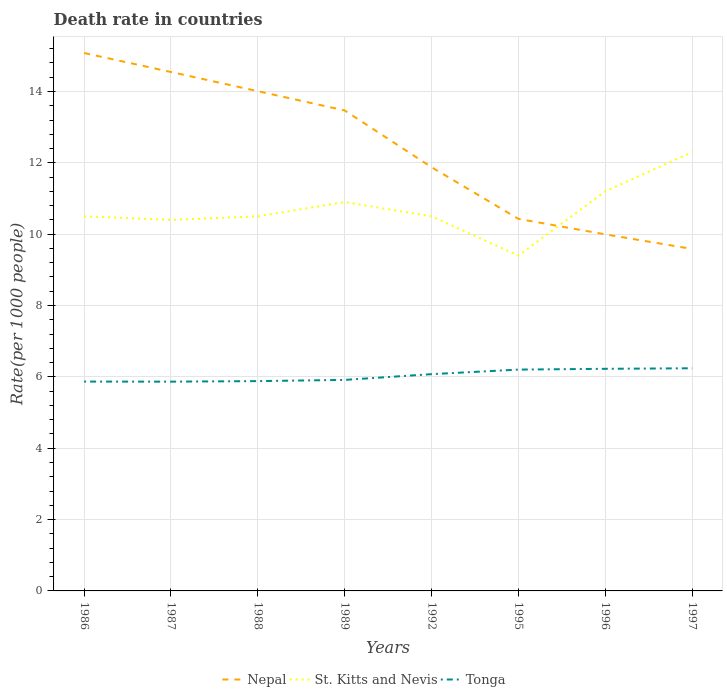Does the line corresponding to Tonga intersect with the line corresponding to Nepal?
Ensure brevity in your answer.  No. Is the number of lines equal to the number of legend labels?
Keep it short and to the point. Yes. Across all years, what is the maximum death rate in Nepal?
Your answer should be very brief. 9.59. What is the total death rate in Tonga in the graph?
Keep it short and to the point. -0.31. What is the difference between the highest and the lowest death rate in Nepal?
Give a very brief answer. 4. Is the death rate in Tonga strictly greater than the death rate in St. Kitts and Nevis over the years?
Provide a short and direct response. Yes. How many lines are there?
Provide a succinct answer. 3. Are the values on the major ticks of Y-axis written in scientific E-notation?
Your answer should be very brief. No. Does the graph contain grids?
Provide a succinct answer. Yes. Where does the legend appear in the graph?
Your answer should be compact. Bottom center. How many legend labels are there?
Your response must be concise. 3. How are the legend labels stacked?
Provide a short and direct response. Horizontal. What is the title of the graph?
Provide a short and direct response. Death rate in countries. What is the label or title of the X-axis?
Make the answer very short. Years. What is the label or title of the Y-axis?
Offer a very short reply. Rate(per 1000 people). What is the Rate(per 1000 people) of Nepal in 1986?
Keep it short and to the point. 15.08. What is the Rate(per 1000 people) of Tonga in 1986?
Provide a succinct answer. 5.87. What is the Rate(per 1000 people) of Nepal in 1987?
Ensure brevity in your answer.  14.55. What is the Rate(per 1000 people) in St. Kitts and Nevis in 1987?
Offer a terse response. 10.4. What is the Rate(per 1000 people) of Tonga in 1987?
Keep it short and to the point. 5.87. What is the Rate(per 1000 people) in Nepal in 1988?
Keep it short and to the point. 14.01. What is the Rate(per 1000 people) in St. Kitts and Nevis in 1988?
Your response must be concise. 10.5. What is the Rate(per 1000 people) in Tonga in 1988?
Your response must be concise. 5.88. What is the Rate(per 1000 people) in Nepal in 1989?
Keep it short and to the point. 13.47. What is the Rate(per 1000 people) of Tonga in 1989?
Ensure brevity in your answer.  5.92. What is the Rate(per 1000 people) in Nepal in 1992?
Offer a very short reply. 11.88. What is the Rate(per 1000 people) of St. Kitts and Nevis in 1992?
Give a very brief answer. 10.5. What is the Rate(per 1000 people) of Tonga in 1992?
Ensure brevity in your answer.  6.08. What is the Rate(per 1000 people) in Nepal in 1995?
Ensure brevity in your answer.  10.43. What is the Rate(per 1000 people) of Tonga in 1995?
Offer a very short reply. 6.2. What is the Rate(per 1000 people) of Nepal in 1996?
Offer a terse response. 9.99. What is the Rate(per 1000 people) of Tonga in 1996?
Your response must be concise. 6.23. What is the Rate(per 1000 people) in Nepal in 1997?
Give a very brief answer. 9.59. What is the Rate(per 1000 people) in St. Kitts and Nevis in 1997?
Keep it short and to the point. 12.3. What is the Rate(per 1000 people) in Tonga in 1997?
Provide a succinct answer. 6.24. Across all years, what is the maximum Rate(per 1000 people) in Nepal?
Your answer should be very brief. 15.08. Across all years, what is the maximum Rate(per 1000 people) in Tonga?
Make the answer very short. 6.24. Across all years, what is the minimum Rate(per 1000 people) in Nepal?
Provide a succinct answer. 9.59. Across all years, what is the minimum Rate(per 1000 people) of Tonga?
Offer a terse response. 5.87. What is the total Rate(per 1000 people) of Nepal in the graph?
Keep it short and to the point. 98.99. What is the total Rate(per 1000 people) in St. Kitts and Nevis in the graph?
Keep it short and to the point. 85.7. What is the total Rate(per 1000 people) of Tonga in the graph?
Offer a very short reply. 48.28. What is the difference between the Rate(per 1000 people) in Nepal in 1986 and that in 1987?
Your response must be concise. 0.53. What is the difference between the Rate(per 1000 people) in St. Kitts and Nevis in 1986 and that in 1987?
Your answer should be very brief. 0.1. What is the difference between the Rate(per 1000 people) of Tonga in 1986 and that in 1987?
Provide a short and direct response. 0. What is the difference between the Rate(per 1000 people) of Nepal in 1986 and that in 1988?
Make the answer very short. 1.07. What is the difference between the Rate(per 1000 people) of Tonga in 1986 and that in 1988?
Offer a very short reply. -0.01. What is the difference between the Rate(per 1000 people) of Nepal in 1986 and that in 1989?
Ensure brevity in your answer.  1.61. What is the difference between the Rate(per 1000 people) in Tonga in 1986 and that in 1989?
Offer a terse response. -0.05. What is the difference between the Rate(per 1000 people) in Nepal in 1986 and that in 1992?
Offer a very short reply. 3.2. What is the difference between the Rate(per 1000 people) in Tonga in 1986 and that in 1992?
Offer a very short reply. -0.21. What is the difference between the Rate(per 1000 people) of Nepal in 1986 and that in 1995?
Your answer should be very brief. 4.65. What is the difference between the Rate(per 1000 people) in Tonga in 1986 and that in 1995?
Provide a succinct answer. -0.34. What is the difference between the Rate(per 1000 people) of Nepal in 1986 and that in 1996?
Give a very brief answer. 5.08. What is the difference between the Rate(per 1000 people) of St. Kitts and Nevis in 1986 and that in 1996?
Your response must be concise. -0.7. What is the difference between the Rate(per 1000 people) of Tonga in 1986 and that in 1996?
Provide a short and direct response. -0.36. What is the difference between the Rate(per 1000 people) of Nepal in 1986 and that in 1997?
Give a very brief answer. 5.49. What is the difference between the Rate(per 1000 people) in Tonga in 1986 and that in 1997?
Keep it short and to the point. -0.37. What is the difference between the Rate(per 1000 people) in Nepal in 1987 and that in 1988?
Keep it short and to the point. 0.54. What is the difference between the Rate(per 1000 people) in Tonga in 1987 and that in 1988?
Provide a short and direct response. -0.01. What is the difference between the Rate(per 1000 people) in Nepal in 1987 and that in 1989?
Give a very brief answer. 1.08. What is the difference between the Rate(per 1000 people) in Tonga in 1987 and that in 1989?
Provide a succinct answer. -0.05. What is the difference between the Rate(per 1000 people) in Nepal in 1987 and that in 1992?
Offer a terse response. 2.67. What is the difference between the Rate(per 1000 people) in St. Kitts and Nevis in 1987 and that in 1992?
Your answer should be very brief. -0.1. What is the difference between the Rate(per 1000 people) of Tonga in 1987 and that in 1992?
Your answer should be compact. -0.21. What is the difference between the Rate(per 1000 people) of Nepal in 1987 and that in 1995?
Provide a short and direct response. 4.12. What is the difference between the Rate(per 1000 people) in Tonga in 1987 and that in 1995?
Give a very brief answer. -0.34. What is the difference between the Rate(per 1000 people) of Nepal in 1987 and that in 1996?
Offer a terse response. 4.55. What is the difference between the Rate(per 1000 people) in Tonga in 1987 and that in 1996?
Your answer should be very brief. -0.36. What is the difference between the Rate(per 1000 people) of Nepal in 1987 and that in 1997?
Make the answer very short. 4.96. What is the difference between the Rate(per 1000 people) in Tonga in 1987 and that in 1997?
Your response must be concise. -0.38. What is the difference between the Rate(per 1000 people) in Nepal in 1988 and that in 1989?
Provide a short and direct response. 0.54. What is the difference between the Rate(per 1000 people) in St. Kitts and Nevis in 1988 and that in 1989?
Give a very brief answer. -0.4. What is the difference between the Rate(per 1000 people) of Tonga in 1988 and that in 1989?
Your response must be concise. -0.03. What is the difference between the Rate(per 1000 people) of Nepal in 1988 and that in 1992?
Give a very brief answer. 2.13. What is the difference between the Rate(per 1000 people) in St. Kitts and Nevis in 1988 and that in 1992?
Make the answer very short. 0. What is the difference between the Rate(per 1000 people) of Tonga in 1988 and that in 1992?
Your answer should be compact. -0.2. What is the difference between the Rate(per 1000 people) in Nepal in 1988 and that in 1995?
Provide a succinct answer. 3.58. What is the difference between the Rate(per 1000 people) of Tonga in 1988 and that in 1995?
Provide a succinct answer. -0.32. What is the difference between the Rate(per 1000 people) in Nepal in 1988 and that in 1996?
Your answer should be very brief. 4.01. What is the difference between the Rate(per 1000 people) of St. Kitts and Nevis in 1988 and that in 1996?
Ensure brevity in your answer.  -0.7. What is the difference between the Rate(per 1000 people) of Tonga in 1988 and that in 1996?
Give a very brief answer. -0.34. What is the difference between the Rate(per 1000 people) of Nepal in 1988 and that in 1997?
Your answer should be compact. 4.42. What is the difference between the Rate(per 1000 people) of St. Kitts and Nevis in 1988 and that in 1997?
Provide a short and direct response. -1.8. What is the difference between the Rate(per 1000 people) of Tonga in 1988 and that in 1997?
Your answer should be very brief. -0.36. What is the difference between the Rate(per 1000 people) in Nepal in 1989 and that in 1992?
Offer a terse response. 1.59. What is the difference between the Rate(per 1000 people) of St. Kitts and Nevis in 1989 and that in 1992?
Your answer should be very brief. 0.4. What is the difference between the Rate(per 1000 people) in Tonga in 1989 and that in 1992?
Provide a short and direct response. -0.16. What is the difference between the Rate(per 1000 people) in Nepal in 1989 and that in 1995?
Keep it short and to the point. 3.04. What is the difference between the Rate(per 1000 people) of Tonga in 1989 and that in 1995?
Your answer should be very brief. -0.29. What is the difference between the Rate(per 1000 people) of Nepal in 1989 and that in 1996?
Provide a short and direct response. 3.47. What is the difference between the Rate(per 1000 people) of Tonga in 1989 and that in 1996?
Provide a succinct answer. -0.31. What is the difference between the Rate(per 1000 people) in Nepal in 1989 and that in 1997?
Provide a short and direct response. 3.88. What is the difference between the Rate(per 1000 people) in St. Kitts and Nevis in 1989 and that in 1997?
Give a very brief answer. -1.4. What is the difference between the Rate(per 1000 people) in Tonga in 1989 and that in 1997?
Your answer should be very brief. -0.33. What is the difference between the Rate(per 1000 people) of Nepal in 1992 and that in 1995?
Provide a succinct answer. 1.45. What is the difference between the Rate(per 1000 people) of St. Kitts and Nevis in 1992 and that in 1995?
Make the answer very short. 1.1. What is the difference between the Rate(per 1000 people) in Tonga in 1992 and that in 1995?
Your response must be concise. -0.13. What is the difference between the Rate(per 1000 people) of Nepal in 1992 and that in 1996?
Offer a terse response. 1.88. What is the difference between the Rate(per 1000 people) in Tonga in 1992 and that in 1996?
Keep it short and to the point. -0.15. What is the difference between the Rate(per 1000 people) of Nepal in 1992 and that in 1997?
Provide a succinct answer. 2.29. What is the difference between the Rate(per 1000 people) of Tonga in 1992 and that in 1997?
Your answer should be very brief. -0.17. What is the difference between the Rate(per 1000 people) of Nepal in 1995 and that in 1996?
Ensure brevity in your answer.  0.43. What is the difference between the Rate(per 1000 people) in St. Kitts and Nevis in 1995 and that in 1996?
Provide a short and direct response. -1.8. What is the difference between the Rate(per 1000 people) of Tonga in 1995 and that in 1996?
Offer a terse response. -0.02. What is the difference between the Rate(per 1000 people) of Nepal in 1995 and that in 1997?
Make the answer very short. 0.84. What is the difference between the Rate(per 1000 people) of Tonga in 1995 and that in 1997?
Your answer should be very brief. -0.04. What is the difference between the Rate(per 1000 people) of Nepal in 1996 and that in 1997?
Provide a succinct answer. 0.41. What is the difference between the Rate(per 1000 people) of Tonga in 1996 and that in 1997?
Keep it short and to the point. -0.01. What is the difference between the Rate(per 1000 people) in Nepal in 1986 and the Rate(per 1000 people) in St. Kitts and Nevis in 1987?
Offer a very short reply. 4.68. What is the difference between the Rate(per 1000 people) of Nepal in 1986 and the Rate(per 1000 people) of Tonga in 1987?
Your answer should be very brief. 9.21. What is the difference between the Rate(per 1000 people) in St. Kitts and Nevis in 1986 and the Rate(per 1000 people) in Tonga in 1987?
Ensure brevity in your answer.  4.63. What is the difference between the Rate(per 1000 people) in Nepal in 1986 and the Rate(per 1000 people) in St. Kitts and Nevis in 1988?
Provide a short and direct response. 4.58. What is the difference between the Rate(per 1000 people) of Nepal in 1986 and the Rate(per 1000 people) of Tonga in 1988?
Your answer should be very brief. 9.2. What is the difference between the Rate(per 1000 people) of St. Kitts and Nevis in 1986 and the Rate(per 1000 people) of Tonga in 1988?
Your answer should be very brief. 4.62. What is the difference between the Rate(per 1000 people) of Nepal in 1986 and the Rate(per 1000 people) of St. Kitts and Nevis in 1989?
Provide a short and direct response. 4.18. What is the difference between the Rate(per 1000 people) in Nepal in 1986 and the Rate(per 1000 people) in Tonga in 1989?
Your answer should be compact. 9.16. What is the difference between the Rate(per 1000 people) in St. Kitts and Nevis in 1986 and the Rate(per 1000 people) in Tonga in 1989?
Your answer should be compact. 4.58. What is the difference between the Rate(per 1000 people) of Nepal in 1986 and the Rate(per 1000 people) of St. Kitts and Nevis in 1992?
Your answer should be compact. 4.58. What is the difference between the Rate(per 1000 people) in Nepal in 1986 and the Rate(per 1000 people) in Tonga in 1992?
Provide a succinct answer. 9. What is the difference between the Rate(per 1000 people) in St. Kitts and Nevis in 1986 and the Rate(per 1000 people) in Tonga in 1992?
Give a very brief answer. 4.42. What is the difference between the Rate(per 1000 people) of Nepal in 1986 and the Rate(per 1000 people) of St. Kitts and Nevis in 1995?
Keep it short and to the point. 5.68. What is the difference between the Rate(per 1000 people) in Nepal in 1986 and the Rate(per 1000 people) in Tonga in 1995?
Provide a succinct answer. 8.87. What is the difference between the Rate(per 1000 people) of St. Kitts and Nevis in 1986 and the Rate(per 1000 people) of Tonga in 1995?
Your response must be concise. 4.3. What is the difference between the Rate(per 1000 people) in Nepal in 1986 and the Rate(per 1000 people) in St. Kitts and Nevis in 1996?
Your answer should be very brief. 3.88. What is the difference between the Rate(per 1000 people) in Nepal in 1986 and the Rate(per 1000 people) in Tonga in 1996?
Keep it short and to the point. 8.85. What is the difference between the Rate(per 1000 people) in St. Kitts and Nevis in 1986 and the Rate(per 1000 people) in Tonga in 1996?
Offer a terse response. 4.27. What is the difference between the Rate(per 1000 people) of Nepal in 1986 and the Rate(per 1000 people) of St. Kitts and Nevis in 1997?
Provide a succinct answer. 2.78. What is the difference between the Rate(per 1000 people) of Nepal in 1986 and the Rate(per 1000 people) of Tonga in 1997?
Keep it short and to the point. 8.84. What is the difference between the Rate(per 1000 people) in St. Kitts and Nevis in 1986 and the Rate(per 1000 people) in Tonga in 1997?
Provide a short and direct response. 4.26. What is the difference between the Rate(per 1000 people) in Nepal in 1987 and the Rate(per 1000 people) in St. Kitts and Nevis in 1988?
Your response must be concise. 4.05. What is the difference between the Rate(per 1000 people) of Nepal in 1987 and the Rate(per 1000 people) of Tonga in 1988?
Make the answer very short. 8.66. What is the difference between the Rate(per 1000 people) of St. Kitts and Nevis in 1987 and the Rate(per 1000 people) of Tonga in 1988?
Make the answer very short. 4.52. What is the difference between the Rate(per 1000 people) in Nepal in 1987 and the Rate(per 1000 people) in St. Kitts and Nevis in 1989?
Provide a short and direct response. 3.65. What is the difference between the Rate(per 1000 people) in Nepal in 1987 and the Rate(per 1000 people) in Tonga in 1989?
Offer a terse response. 8.63. What is the difference between the Rate(per 1000 people) of St. Kitts and Nevis in 1987 and the Rate(per 1000 people) of Tonga in 1989?
Offer a very short reply. 4.49. What is the difference between the Rate(per 1000 people) in Nepal in 1987 and the Rate(per 1000 people) in St. Kitts and Nevis in 1992?
Make the answer very short. 4.05. What is the difference between the Rate(per 1000 people) in Nepal in 1987 and the Rate(per 1000 people) in Tonga in 1992?
Your response must be concise. 8.47. What is the difference between the Rate(per 1000 people) of St. Kitts and Nevis in 1987 and the Rate(per 1000 people) of Tonga in 1992?
Provide a short and direct response. 4.32. What is the difference between the Rate(per 1000 people) in Nepal in 1987 and the Rate(per 1000 people) in St. Kitts and Nevis in 1995?
Your answer should be very brief. 5.15. What is the difference between the Rate(per 1000 people) in Nepal in 1987 and the Rate(per 1000 people) in Tonga in 1995?
Make the answer very short. 8.34. What is the difference between the Rate(per 1000 people) in St. Kitts and Nevis in 1987 and the Rate(per 1000 people) in Tonga in 1995?
Keep it short and to the point. 4.2. What is the difference between the Rate(per 1000 people) of Nepal in 1987 and the Rate(per 1000 people) of St. Kitts and Nevis in 1996?
Give a very brief answer. 3.35. What is the difference between the Rate(per 1000 people) of Nepal in 1987 and the Rate(per 1000 people) of Tonga in 1996?
Provide a succinct answer. 8.32. What is the difference between the Rate(per 1000 people) in St. Kitts and Nevis in 1987 and the Rate(per 1000 people) in Tonga in 1996?
Offer a terse response. 4.17. What is the difference between the Rate(per 1000 people) in Nepal in 1987 and the Rate(per 1000 people) in St. Kitts and Nevis in 1997?
Provide a succinct answer. 2.25. What is the difference between the Rate(per 1000 people) in Nepal in 1987 and the Rate(per 1000 people) in Tonga in 1997?
Your answer should be compact. 8.3. What is the difference between the Rate(per 1000 people) of St. Kitts and Nevis in 1987 and the Rate(per 1000 people) of Tonga in 1997?
Keep it short and to the point. 4.16. What is the difference between the Rate(per 1000 people) of Nepal in 1988 and the Rate(per 1000 people) of St. Kitts and Nevis in 1989?
Provide a short and direct response. 3.11. What is the difference between the Rate(per 1000 people) in Nepal in 1988 and the Rate(per 1000 people) in Tonga in 1989?
Offer a very short reply. 8.09. What is the difference between the Rate(per 1000 people) of St. Kitts and Nevis in 1988 and the Rate(per 1000 people) of Tonga in 1989?
Your response must be concise. 4.58. What is the difference between the Rate(per 1000 people) of Nepal in 1988 and the Rate(per 1000 people) of St. Kitts and Nevis in 1992?
Provide a short and direct response. 3.51. What is the difference between the Rate(per 1000 people) of Nepal in 1988 and the Rate(per 1000 people) of Tonga in 1992?
Ensure brevity in your answer.  7.93. What is the difference between the Rate(per 1000 people) of St. Kitts and Nevis in 1988 and the Rate(per 1000 people) of Tonga in 1992?
Your answer should be very brief. 4.42. What is the difference between the Rate(per 1000 people) of Nepal in 1988 and the Rate(per 1000 people) of St. Kitts and Nevis in 1995?
Your answer should be very brief. 4.61. What is the difference between the Rate(per 1000 people) of Nepal in 1988 and the Rate(per 1000 people) of Tonga in 1995?
Ensure brevity in your answer.  7.8. What is the difference between the Rate(per 1000 people) of St. Kitts and Nevis in 1988 and the Rate(per 1000 people) of Tonga in 1995?
Offer a very short reply. 4.3. What is the difference between the Rate(per 1000 people) of Nepal in 1988 and the Rate(per 1000 people) of St. Kitts and Nevis in 1996?
Offer a very short reply. 2.81. What is the difference between the Rate(per 1000 people) in Nepal in 1988 and the Rate(per 1000 people) in Tonga in 1996?
Offer a terse response. 7.78. What is the difference between the Rate(per 1000 people) in St. Kitts and Nevis in 1988 and the Rate(per 1000 people) in Tonga in 1996?
Your answer should be compact. 4.27. What is the difference between the Rate(per 1000 people) of Nepal in 1988 and the Rate(per 1000 people) of St. Kitts and Nevis in 1997?
Give a very brief answer. 1.71. What is the difference between the Rate(per 1000 people) in Nepal in 1988 and the Rate(per 1000 people) in Tonga in 1997?
Give a very brief answer. 7.77. What is the difference between the Rate(per 1000 people) of St. Kitts and Nevis in 1988 and the Rate(per 1000 people) of Tonga in 1997?
Ensure brevity in your answer.  4.26. What is the difference between the Rate(per 1000 people) in Nepal in 1989 and the Rate(per 1000 people) in St. Kitts and Nevis in 1992?
Provide a short and direct response. 2.97. What is the difference between the Rate(per 1000 people) in Nepal in 1989 and the Rate(per 1000 people) in Tonga in 1992?
Keep it short and to the point. 7.39. What is the difference between the Rate(per 1000 people) in St. Kitts and Nevis in 1989 and the Rate(per 1000 people) in Tonga in 1992?
Provide a succinct answer. 4.82. What is the difference between the Rate(per 1000 people) in Nepal in 1989 and the Rate(per 1000 people) in St. Kitts and Nevis in 1995?
Provide a succinct answer. 4.07. What is the difference between the Rate(per 1000 people) of Nepal in 1989 and the Rate(per 1000 people) of Tonga in 1995?
Your response must be concise. 7.26. What is the difference between the Rate(per 1000 people) of St. Kitts and Nevis in 1989 and the Rate(per 1000 people) of Tonga in 1995?
Offer a terse response. 4.7. What is the difference between the Rate(per 1000 people) of Nepal in 1989 and the Rate(per 1000 people) of St. Kitts and Nevis in 1996?
Offer a terse response. 2.27. What is the difference between the Rate(per 1000 people) of Nepal in 1989 and the Rate(per 1000 people) of Tonga in 1996?
Your response must be concise. 7.24. What is the difference between the Rate(per 1000 people) in St. Kitts and Nevis in 1989 and the Rate(per 1000 people) in Tonga in 1996?
Your answer should be compact. 4.67. What is the difference between the Rate(per 1000 people) of Nepal in 1989 and the Rate(per 1000 people) of St. Kitts and Nevis in 1997?
Give a very brief answer. 1.17. What is the difference between the Rate(per 1000 people) in Nepal in 1989 and the Rate(per 1000 people) in Tonga in 1997?
Ensure brevity in your answer.  7.23. What is the difference between the Rate(per 1000 people) of St. Kitts and Nevis in 1989 and the Rate(per 1000 people) of Tonga in 1997?
Make the answer very short. 4.66. What is the difference between the Rate(per 1000 people) in Nepal in 1992 and the Rate(per 1000 people) in St. Kitts and Nevis in 1995?
Your response must be concise. 2.48. What is the difference between the Rate(per 1000 people) in Nepal in 1992 and the Rate(per 1000 people) in Tonga in 1995?
Keep it short and to the point. 5.67. What is the difference between the Rate(per 1000 people) of St. Kitts and Nevis in 1992 and the Rate(per 1000 people) of Tonga in 1995?
Your answer should be very brief. 4.3. What is the difference between the Rate(per 1000 people) in Nepal in 1992 and the Rate(per 1000 people) in St. Kitts and Nevis in 1996?
Offer a very short reply. 0.68. What is the difference between the Rate(per 1000 people) in Nepal in 1992 and the Rate(per 1000 people) in Tonga in 1996?
Provide a succinct answer. 5.65. What is the difference between the Rate(per 1000 people) in St. Kitts and Nevis in 1992 and the Rate(per 1000 people) in Tonga in 1996?
Your answer should be compact. 4.27. What is the difference between the Rate(per 1000 people) of Nepal in 1992 and the Rate(per 1000 people) of St. Kitts and Nevis in 1997?
Ensure brevity in your answer.  -0.42. What is the difference between the Rate(per 1000 people) of Nepal in 1992 and the Rate(per 1000 people) of Tonga in 1997?
Make the answer very short. 5.64. What is the difference between the Rate(per 1000 people) in St. Kitts and Nevis in 1992 and the Rate(per 1000 people) in Tonga in 1997?
Provide a short and direct response. 4.26. What is the difference between the Rate(per 1000 people) of Nepal in 1995 and the Rate(per 1000 people) of St. Kitts and Nevis in 1996?
Your answer should be compact. -0.77. What is the difference between the Rate(per 1000 people) of Nepal in 1995 and the Rate(per 1000 people) of Tonga in 1996?
Provide a short and direct response. 4.2. What is the difference between the Rate(per 1000 people) in St. Kitts and Nevis in 1995 and the Rate(per 1000 people) in Tonga in 1996?
Your answer should be very brief. 3.17. What is the difference between the Rate(per 1000 people) of Nepal in 1995 and the Rate(per 1000 people) of St. Kitts and Nevis in 1997?
Provide a succinct answer. -1.87. What is the difference between the Rate(per 1000 people) of Nepal in 1995 and the Rate(per 1000 people) of Tonga in 1997?
Ensure brevity in your answer.  4.19. What is the difference between the Rate(per 1000 people) of St. Kitts and Nevis in 1995 and the Rate(per 1000 people) of Tonga in 1997?
Offer a very short reply. 3.16. What is the difference between the Rate(per 1000 people) in Nepal in 1996 and the Rate(per 1000 people) in St. Kitts and Nevis in 1997?
Offer a terse response. -2.31. What is the difference between the Rate(per 1000 people) of Nepal in 1996 and the Rate(per 1000 people) of Tonga in 1997?
Offer a very short reply. 3.75. What is the difference between the Rate(per 1000 people) of St. Kitts and Nevis in 1996 and the Rate(per 1000 people) of Tonga in 1997?
Keep it short and to the point. 4.96. What is the average Rate(per 1000 people) of Nepal per year?
Give a very brief answer. 12.37. What is the average Rate(per 1000 people) of St. Kitts and Nevis per year?
Your response must be concise. 10.71. What is the average Rate(per 1000 people) of Tonga per year?
Provide a short and direct response. 6.03. In the year 1986, what is the difference between the Rate(per 1000 people) in Nepal and Rate(per 1000 people) in St. Kitts and Nevis?
Make the answer very short. 4.58. In the year 1986, what is the difference between the Rate(per 1000 people) of Nepal and Rate(per 1000 people) of Tonga?
Make the answer very short. 9.21. In the year 1986, what is the difference between the Rate(per 1000 people) of St. Kitts and Nevis and Rate(per 1000 people) of Tonga?
Your answer should be compact. 4.63. In the year 1987, what is the difference between the Rate(per 1000 people) of Nepal and Rate(per 1000 people) of St. Kitts and Nevis?
Your response must be concise. 4.15. In the year 1987, what is the difference between the Rate(per 1000 people) of Nepal and Rate(per 1000 people) of Tonga?
Provide a short and direct response. 8.68. In the year 1987, what is the difference between the Rate(per 1000 people) in St. Kitts and Nevis and Rate(per 1000 people) in Tonga?
Offer a terse response. 4.53. In the year 1988, what is the difference between the Rate(per 1000 people) of Nepal and Rate(per 1000 people) of St. Kitts and Nevis?
Your answer should be very brief. 3.51. In the year 1988, what is the difference between the Rate(per 1000 people) in Nepal and Rate(per 1000 people) in Tonga?
Provide a short and direct response. 8.13. In the year 1988, what is the difference between the Rate(per 1000 people) in St. Kitts and Nevis and Rate(per 1000 people) in Tonga?
Give a very brief answer. 4.62. In the year 1989, what is the difference between the Rate(per 1000 people) of Nepal and Rate(per 1000 people) of St. Kitts and Nevis?
Give a very brief answer. 2.57. In the year 1989, what is the difference between the Rate(per 1000 people) of Nepal and Rate(per 1000 people) of Tonga?
Offer a very short reply. 7.55. In the year 1989, what is the difference between the Rate(per 1000 people) in St. Kitts and Nevis and Rate(per 1000 people) in Tonga?
Your response must be concise. 4.99. In the year 1992, what is the difference between the Rate(per 1000 people) of Nepal and Rate(per 1000 people) of St. Kitts and Nevis?
Provide a short and direct response. 1.38. In the year 1992, what is the difference between the Rate(per 1000 people) of Nepal and Rate(per 1000 people) of Tonga?
Your answer should be very brief. 5.8. In the year 1992, what is the difference between the Rate(per 1000 people) in St. Kitts and Nevis and Rate(per 1000 people) in Tonga?
Make the answer very short. 4.42. In the year 1995, what is the difference between the Rate(per 1000 people) in Nepal and Rate(per 1000 people) in St. Kitts and Nevis?
Your answer should be compact. 1.03. In the year 1995, what is the difference between the Rate(per 1000 people) in Nepal and Rate(per 1000 people) in Tonga?
Your response must be concise. 4.22. In the year 1995, what is the difference between the Rate(per 1000 people) of St. Kitts and Nevis and Rate(per 1000 people) of Tonga?
Offer a very short reply. 3.2. In the year 1996, what is the difference between the Rate(per 1000 people) of Nepal and Rate(per 1000 people) of St. Kitts and Nevis?
Keep it short and to the point. -1.21. In the year 1996, what is the difference between the Rate(per 1000 people) of Nepal and Rate(per 1000 people) of Tonga?
Provide a short and direct response. 3.77. In the year 1996, what is the difference between the Rate(per 1000 people) of St. Kitts and Nevis and Rate(per 1000 people) of Tonga?
Make the answer very short. 4.97. In the year 1997, what is the difference between the Rate(per 1000 people) of Nepal and Rate(per 1000 people) of St. Kitts and Nevis?
Give a very brief answer. -2.71. In the year 1997, what is the difference between the Rate(per 1000 people) of Nepal and Rate(per 1000 people) of Tonga?
Make the answer very short. 3.35. In the year 1997, what is the difference between the Rate(per 1000 people) in St. Kitts and Nevis and Rate(per 1000 people) in Tonga?
Provide a short and direct response. 6.06. What is the ratio of the Rate(per 1000 people) in Nepal in 1986 to that in 1987?
Make the answer very short. 1.04. What is the ratio of the Rate(per 1000 people) in St. Kitts and Nevis in 1986 to that in 1987?
Your answer should be compact. 1.01. What is the ratio of the Rate(per 1000 people) in Nepal in 1986 to that in 1988?
Your response must be concise. 1.08. What is the ratio of the Rate(per 1000 people) of Nepal in 1986 to that in 1989?
Offer a very short reply. 1.12. What is the ratio of the Rate(per 1000 people) in St. Kitts and Nevis in 1986 to that in 1989?
Offer a terse response. 0.96. What is the ratio of the Rate(per 1000 people) of Tonga in 1986 to that in 1989?
Provide a short and direct response. 0.99. What is the ratio of the Rate(per 1000 people) of Nepal in 1986 to that in 1992?
Your answer should be very brief. 1.27. What is the ratio of the Rate(per 1000 people) of St. Kitts and Nevis in 1986 to that in 1992?
Make the answer very short. 1. What is the ratio of the Rate(per 1000 people) of Tonga in 1986 to that in 1992?
Offer a very short reply. 0.97. What is the ratio of the Rate(per 1000 people) of Nepal in 1986 to that in 1995?
Offer a very short reply. 1.45. What is the ratio of the Rate(per 1000 people) in St. Kitts and Nevis in 1986 to that in 1995?
Provide a succinct answer. 1.12. What is the ratio of the Rate(per 1000 people) in Tonga in 1986 to that in 1995?
Your answer should be very brief. 0.95. What is the ratio of the Rate(per 1000 people) of Nepal in 1986 to that in 1996?
Ensure brevity in your answer.  1.51. What is the ratio of the Rate(per 1000 people) in Tonga in 1986 to that in 1996?
Your answer should be very brief. 0.94. What is the ratio of the Rate(per 1000 people) in Nepal in 1986 to that in 1997?
Your answer should be compact. 1.57. What is the ratio of the Rate(per 1000 people) of St. Kitts and Nevis in 1986 to that in 1997?
Your answer should be very brief. 0.85. What is the ratio of the Rate(per 1000 people) in Tonga in 1986 to that in 1997?
Give a very brief answer. 0.94. What is the ratio of the Rate(per 1000 people) of Nepal in 1987 to that in 1988?
Provide a succinct answer. 1.04. What is the ratio of the Rate(per 1000 people) of Tonga in 1987 to that in 1988?
Give a very brief answer. 1. What is the ratio of the Rate(per 1000 people) of St. Kitts and Nevis in 1987 to that in 1989?
Your answer should be compact. 0.95. What is the ratio of the Rate(per 1000 people) in Nepal in 1987 to that in 1992?
Keep it short and to the point. 1.22. What is the ratio of the Rate(per 1000 people) of Tonga in 1987 to that in 1992?
Make the answer very short. 0.97. What is the ratio of the Rate(per 1000 people) of Nepal in 1987 to that in 1995?
Offer a very short reply. 1.39. What is the ratio of the Rate(per 1000 people) in St. Kitts and Nevis in 1987 to that in 1995?
Offer a very short reply. 1.11. What is the ratio of the Rate(per 1000 people) in Tonga in 1987 to that in 1995?
Ensure brevity in your answer.  0.95. What is the ratio of the Rate(per 1000 people) of Nepal in 1987 to that in 1996?
Ensure brevity in your answer.  1.46. What is the ratio of the Rate(per 1000 people) in Tonga in 1987 to that in 1996?
Ensure brevity in your answer.  0.94. What is the ratio of the Rate(per 1000 people) in Nepal in 1987 to that in 1997?
Your answer should be compact. 1.52. What is the ratio of the Rate(per 1000 people) in St. Kitts and Nevis in 1987 to that in 1997?
Offer a terse response. 0.85. What is the ratio of the Rate(per 1000 people) in Tonga in 1987 to that in 1997?
Provide a short and direct response. 0.94. What is the ratio of the Rate(per 1000 people) of Nepal in 1988 to that in 1989?
Give a very brief answer. 1.04. What is the ratio of the Rate(per 1000 people) of St. Kitts and Nevis in 1988 to that in 1989?
Offer a very short reply. 0.96. What is the ratio of the Rate(per 1000 people) in Tonga in 1988 to that in 1989?
Your answer should be very brief. 0.99. What is the ratio of the Rate(per 1000 people) of Nepal in 1988 to that in 1992?
Your response must be concise. 1.18. What is the ratio of the Rate(per 1000 people) of St. Kitts and Nevis in 1988 to that in 1992?
Your answer should be very brief. 1. What is the ratio of the Rate(per 1000 people) of Tonga in 1988 to that in 1992?
Make the answer very short. 0.97. What is the ratio of the Rate(per 1000 people) in Nepal in 1988 to that in 1995?
Your response must be concise. 1.34. What is the ratio of the Rate(per 1000 people) of St. Kitts and Nevis in 1988 to that in 1995?
Offer a terse response. 1.12. What is the ratio of the Rate(per 1000 people) of Tonga in 1988 to that in 1995?
Make the answer very short. 0.95. What is the ratio of the Rate(per 1000 people) of Nepal in 1988 to that in 1996?
Offer a very short reply. 1.4. What is the ratio of the Rate(per 1000 people) of Tonga in 1988 to that in 1996?
Ensure brevity in your answer.  0.94. What is the ratio of the Rate(per 1000 people) in Nepal in 1988 to that in 1997?
Provide a short and direct response. 1.46. What is the ratio of the Rate(per 1000 people) of St. Kitts and Nevis in 1988 to that in 1997?
Your answer should be very brief. 0.85. What is the ratio of the Rate(per 1000 people) of Tonga in 1988 to that in 1997?
Ensure brevity in your answer.  0.94. What is the ratio of the Rate(per 1000 people) of Nepal in 1989 to that in 1992?
Your answer should be very brief. 1.13. What is the ratio of the Rate(per 1000 people) of St. Kitts and Nevis in 1989 to that in 1992?
Give a very brief answer. 1.04. What is the ratio of the Rate(per 1000 people) in Tonga in 1989 to that in 1992?
Provide a short and direct response. 0.97. What is the ratio of the Rate(per 1000 people) of Nepal in 1989 to that in 1995?
Offer a very short reply. 1.29. What is the ratio of the Rate(per 1000 people) in St. Kitts and Nevis in 1989 to that in 1995?
Provide a short and direct response. 1.16. What is the ratio of the Rate(per 1000 people) in Tonga in 1989 to that in 1995?
Provide a short and direct response. 0.95. What is the ratio of the Rate(per 1000 people) of Nepal in 1989 to that in 1996?
Provide a succinct answer. 1.35. What is the ratio of the Rate(per 1000 people) of St. Kitts and Nevis in 1989 to that in 1996?
Keep it short and to the point. 0.97. What is the ratio of the Rate(per 1000 people) in Nepal in 1989 to that in 1997?
Make the answer very short. 1.41. What is the ratio of the Rate(per 1000 people) of St. Kitts and Nevis in 1989 to that in 1997?
Provide a short and direct response. 0.89. What is the ratio of the Rate(per 1000 people) in Tonga in 1989 to that in 1997?
Make the answer very short. 0.95. What is the ratio of the Rate(per 1000 people) of Nepal in 1992 to that in 1995?
Provide a succinct answer. 1.14. What is the ratio of the Rate(per 1000 people) of St. Kitts and Nevis in 1992 to that in 1995?
Your response must be concise. 1.12. What is the ratio of the Rate(per 1000 people) of Tonga in 1992 to that in 1995?
Ensure brevity in your answer.  0.98. What is the ratio of the Rate(per 1000 people) of Nepal in 1992 to that in 1996?
Make the answer very short. 1.19. What is the ratio of the Rate(per 1000 people) of St. Kitts and Nevis in 1992 to that in 1996?
Your response must be concise. 0.94. What is the ratio of the Rate(per 1000 people) in Tonga in 1992 to that in 1996?
Your response must be concise. 0.98. What is the ratio of the Rate(per 1000 people) of Nepal in 1992 to that in 1997?
Offer a terse response. 1.24. What is the ratio of the Rate(per 1000 people) in St. Kitts and Nevis in 1992 to that in 1997?
Your response must be concise. 0.85. What is the ratio of the Rate(per 1000 people) of Tonga in 1992 to that in 1997?
Your answer should be compact. 0.97. What is the ratio of the Rate(per 1000 people) of Nepal in 1995 to that in 1996?
Offer a terse response. 1.04. What is the ratio of the Rate(per 1000 people) in St. Kitts and Nevis in 1995 to that in 1996?
Provide a short and direct response. 0.84. What is the ratio of the Rate(per 1000 people) in Nepal in 1995 to that in 1997?
Provide a succinct answer. 1.09. What is the ratio of the Rate(per 1000 people) of St. Kitts and Nevis in 1995 to that in 1997?
Ensure brevity in your answer.  0.76. What is the ratio of the Rate(per 1000 people) of Nepal in 1996 to that in 1997?
Ensure brevity in your answer.  1.04. What is the ratio of the Rate(per 1000 people) of St. Kitts and Nevis in 1996 to that in 1997?
Keep it short and to the point. 0.91. What is the ratio of the Rate(per 1000 people) of Tonga in 1996 to that in 1997?
Your answer should be very brief. 1. What is the difference between the highest and the second highest Rate(per 1000 people) in Nepal?
Your response must be concise. 0.53. What is the difference between the highest and the second highest Rate(per 1000 people) in St. Kitts and Nevis?
Provide a short and direct response. 1.1. What is the difference between the highest and the second highest Rate(per 1000 people) in Tonga?
Offer a terse response. 0.01. What is the difference between the highest and the lowest Rate(per 1000 people) in Nepal?
Your answer should be compact. 5.49. What is the difference between the highest and the lowest Rate(per 1000 people) of Tonga?
Give a very brief answer. 0.38. 